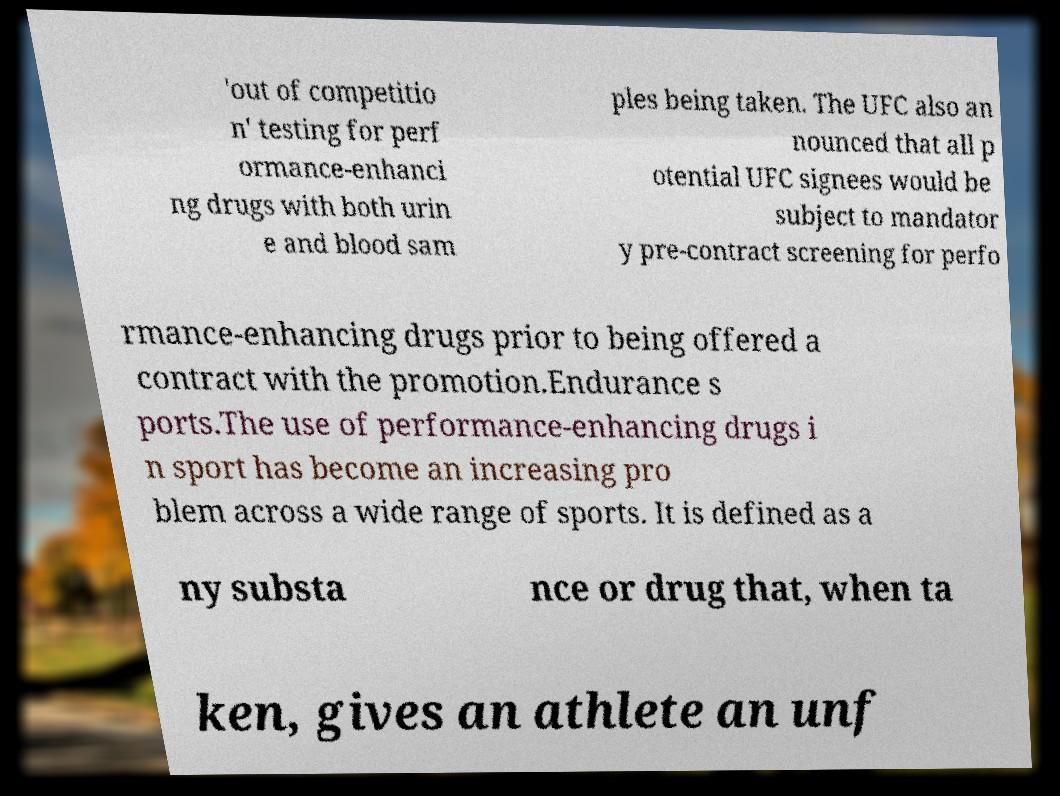Please identify and transcribe the text found in this image. 'out of competitio n' testing for perf ormance-enhanci ng drugs with both urin e and blood sam ples being taken. The UFC also an nounced that all p otential UFC signees would be subject to mandator y pre-contract screening for perfo rmance-enhancing drugs prior to being offered a contract with the promotion.Endurance s ports.The use of performance-enhancing drugs i n sport has become an increasing pro blem across a wide range of sports. It is defined as a ny substa nce or drug that, when ta ken, gives an athlete an unf 